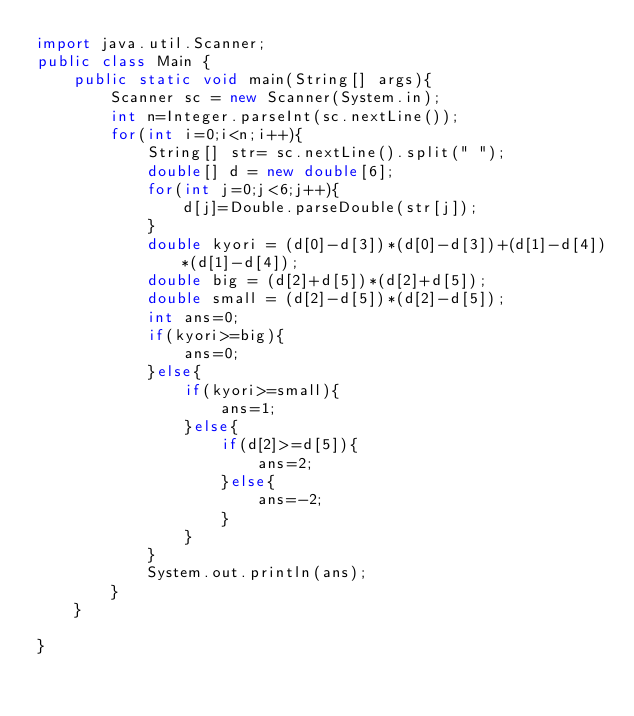<code> <loc_0><loc_0><loc_500><loc_500><_Java_>import java.util.Scanner;
public class Main {
    public static void main(String[] args){
        Scanner sc = new Scanner(System.in);
        int n=Integer.parseInt(sc.nextLine());
        for(int i=0;i<n;i++){
            String[] str= sc.nextLine().split(" ");
            double[] d = new double[6];
            for(int j=0;j<6;j++){
                d[j]=Double.parseDouble(str[j]);
            }
            double kyori = (d[0]-d[3])*(d[0]-d[3])+(d[1]-d[4])*(d[1]-d[4]);
            double big = (d[2]+d[5])*(d[2]+d[5]);
            double small = (d[2]-d[5])*(d[2]-d[5]);
            int ans=0;
            if(kyori>=big){
                ans=0;
            }else{
                if(kyori>=small){
                    ans=1;
                }else{
                    if(d[2]>=d[5]){
                        ans=2;
                    }else{
                        ans=-2;
                    }
                }
            }
            System.out.println(ans);
        }
    }
    
}</code> 